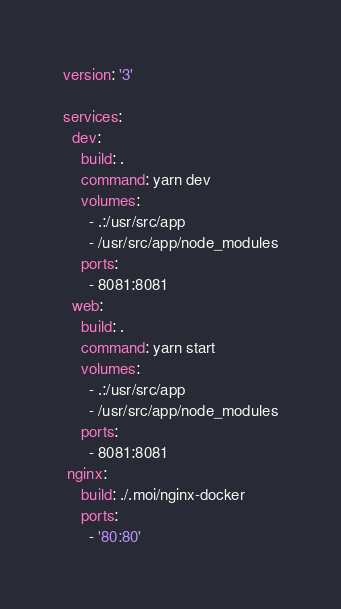Convert code to text. <code><loc_0><loc_0><loc_500><loc_500><_YAML_>version: '3'

services:
  dev:
    build: .
    command: yarn dev
    volumes:
      - .:/usr/src/app
      - /usr/src/app/node_modules
    ports:
      - 8081:8081
  web:
    build: .
    command: yarn start
    volumes:
      - .:/usr/src/app
      - /usr/src/app/node_modules
    ports:
      - 8081:8081
 nginx:
    build: ./.moi/nginx-docker
    ports:
      - '80:80'
</code> 